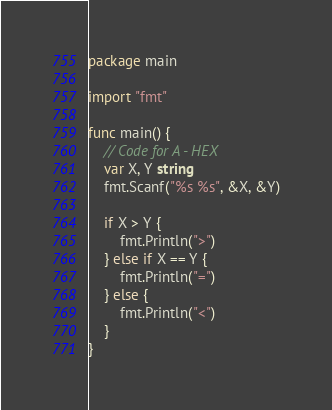Convert code to text. <code><loc_0><loc_0><loc_500><loc_500><_Go_>package main

import "fmt"

func main() {
	// Code for A - HEX
	var X, Y string
	fmt.Scanf("%s %s", &X, &Y)

	if X > Y {
		fmt.Println(">")
	} else if X == Y {
		fmt.Println("=")
	} else {
		fmt.Println("<")
	}
}
</code> 